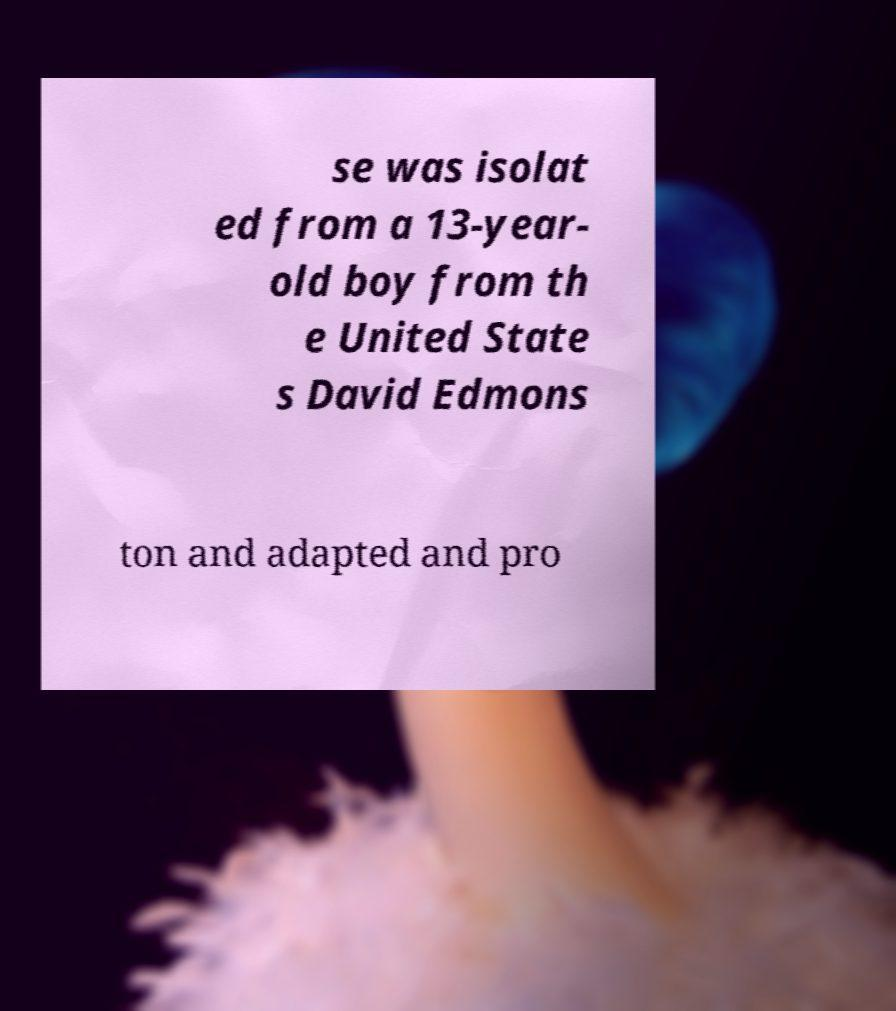For documentation purposes, I need the text within this image transcribed. Could you provide that? se was isolat ed from a 13-year- old boy from th e United State s David Edmons ton and adapted and pro 